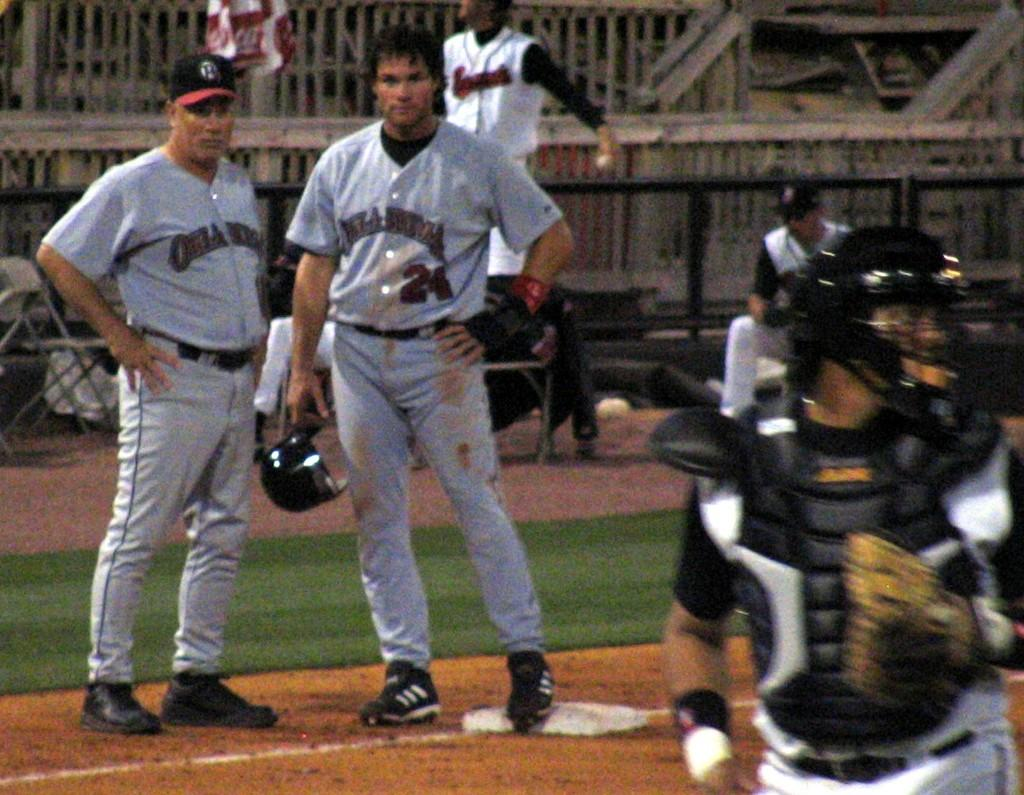<image>
Offer a succinct explanation of the picture presented. Two pro ball players in Oklahoma uniforms confer mid-game. 